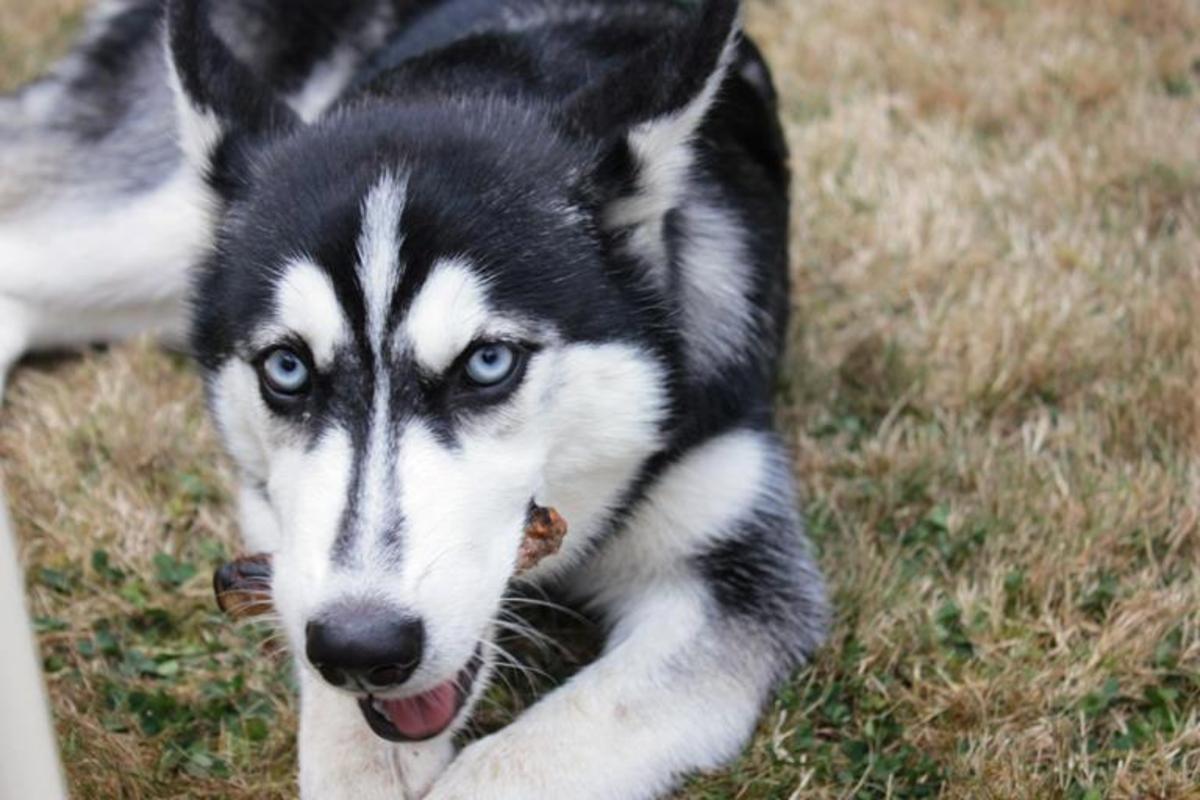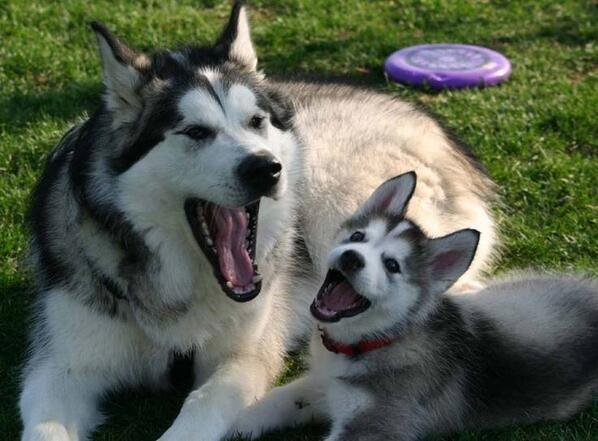The first image is the image on the left, the second image is the image on the right. For the images displayed, is the sentence "The left and right image contains the same number of dogs." factually correct? Answer yes or no. No. The first image is the image on the left, the second image is the image on the right. Considering the images on both sides, is "There are exactly three dogs." valid? Answer yes or no. Yes. 